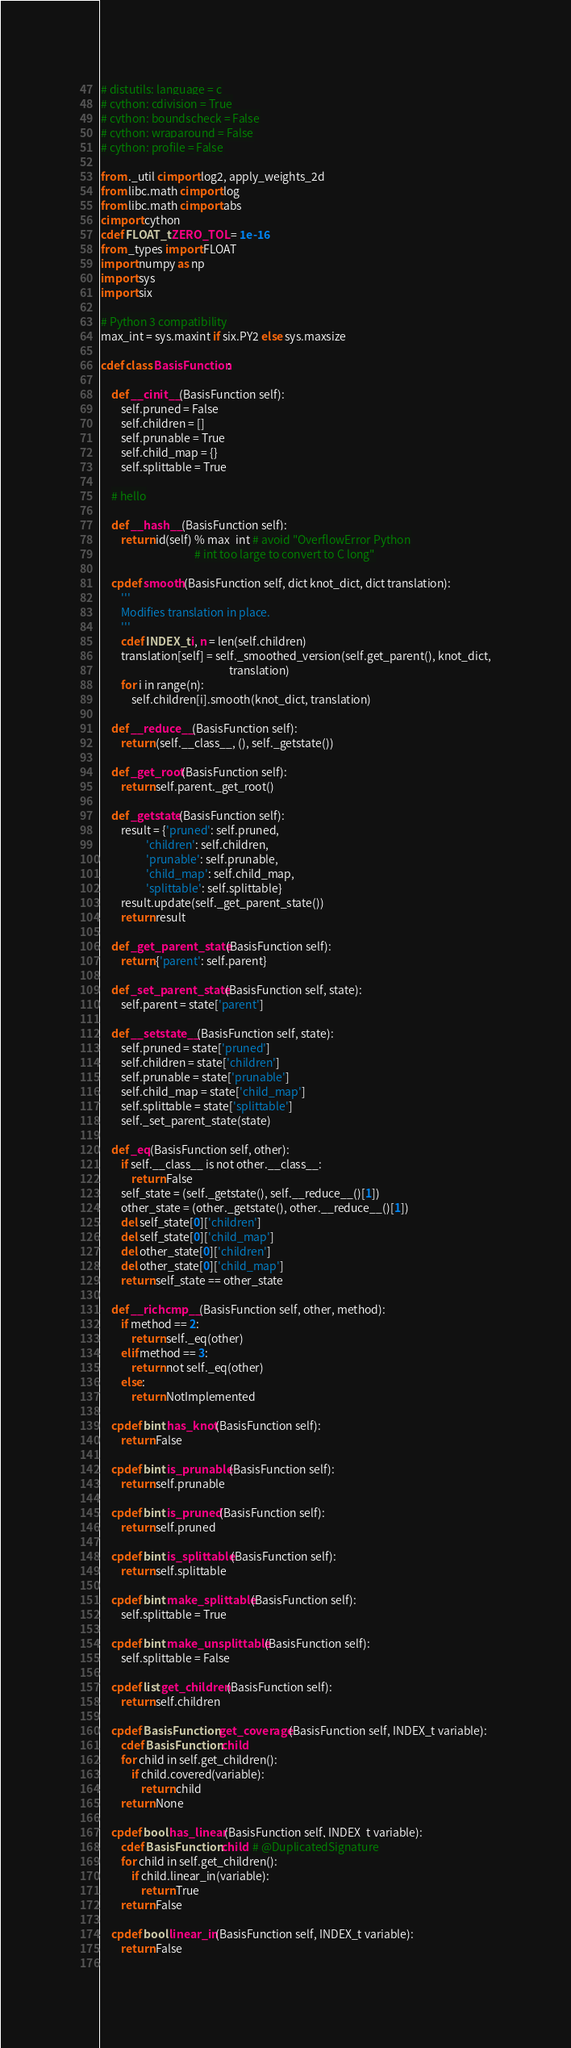<code> <loc_0><loc_0><loc_500><loc_500><_Cython_># distutils: language = c
# cython: cdivision = True
# cython: boundscheck = False
# cython: wraparound = False
# cython: profile = False

from ._util cimport log2, apply_weights_2d
from libc.math cimport log
from libc.math cimport abs
cimport cython
cdef FLOAT_t ZERO_TOL = 1e-16
from _types import FLOAT
import numpy as np
import sys
import six

# Python 3 compatibility
max_int = sys.maxint if six.PY2 else sys.maxsize

cdef class BasisFunction:

    def __cinit__(BasisFunction self):
        self.pruned = False
        self.children = []
        self.prunable = True
        self.child_map = {}
        self.splittable = True
		
	# hello

    def __hash__(BasisFunction self):
        return id(self) % max_int # avoid "OverflowError Python
                                     # int too large to convert to C long"
    
    cpdef smooth(BasisFunction self, dict knot_dict, dict translation):
        '''
        Modifies translation in place.
        '''
        cdef INDEX_t i, n = len(self.children)
        translation[self] = self._smoothed_version(self.get_parent(), knot_dict,
                                                   translation)
        for i in range(n):
            self.children[i].smooth(knot_dict, translation)
    
    def __reduce__(BasisFunction self):
        return (self.__class__, (), self._getstate())

    def _get_root(BasisFunction self):
        return self.parent._get_root()

    def _getstate(BasisFunction self):
        result = {'pruned': self.pruned,
                  'children': self.children,
                  'prunable': self.prunable,
                  'child_map': self.child_map,
                  'splittable': self.splittable}
        result.update(self._get_parent_state())
        return result

    def _get_parent_state(BasisFunction self):
        return {'parent': self.parent}

    def _set_parent_state(BasisFunction self, state):
        self.parent = state['parent']

    def __setstate__(BasisFunction self, state):
        self.pruned = state['pruned']
        self.children = state['children']
        self.prunable = state['prunable']
        self.child_map = state['child_map']
        self.splittable = state['splittable']
        self._set_parent_state(state)

    def _eq(BasisFunction self, other):
        if self.__class__ is not other.__class__:
            return False
        self_state = (self._getstate(), self.__reduce__()[1])
        other_state = (other._getstate(), other.__reduce__()[1])
        del self_state[0]['children']
        del self_state[0]['child_map']
        del other_state[0]['children']
        del other_state[0]['child_map']
        return self_state == other_state

    def __richcmp__(BasisFunction self, other, method):
        if method == 2:
            return self._eq(other)
        elif method == 3:
            return not self._eq(other)
        else:
            return NotImplemented

    cpdef bint has_knot(BasisFunction self):
        return False

    cpdef bint is_prunable(BasisFunction self):
        return self.prunable

    cpdef bint is_pruned(BasisFunction self):
        return self.pruned

    cpdef bint is_splittable(BasisFunction self):
        return self.splittable

    cpdef bint make_splittable(BasisFunction self):
        self.splittable = True

    cpdef bint make_unsplittable(BasisFunction self):
        self.splittable = False

    cpdef list get_children(BasisFunction self):
        return self.children
    
    cpdef BasisFunction get_coverage(BasisFunction self, INDEX_t variable):
        cdef BasisFunction child
        for child in self.get_children():
            if child.covered(variable):
                return child
        return None
    
    cpdef bool has_linear(BasisFunction self, INDEX_t variable):
        cdef BasisFunction child  # @DuplicatedSignature
        for child in self.get_children():
            if child.linear_in(variable):
                return True
        return False
    
    cpdef bool linear_in(BasisFunction self, INDEX_t variable):
        return False
    </code> 